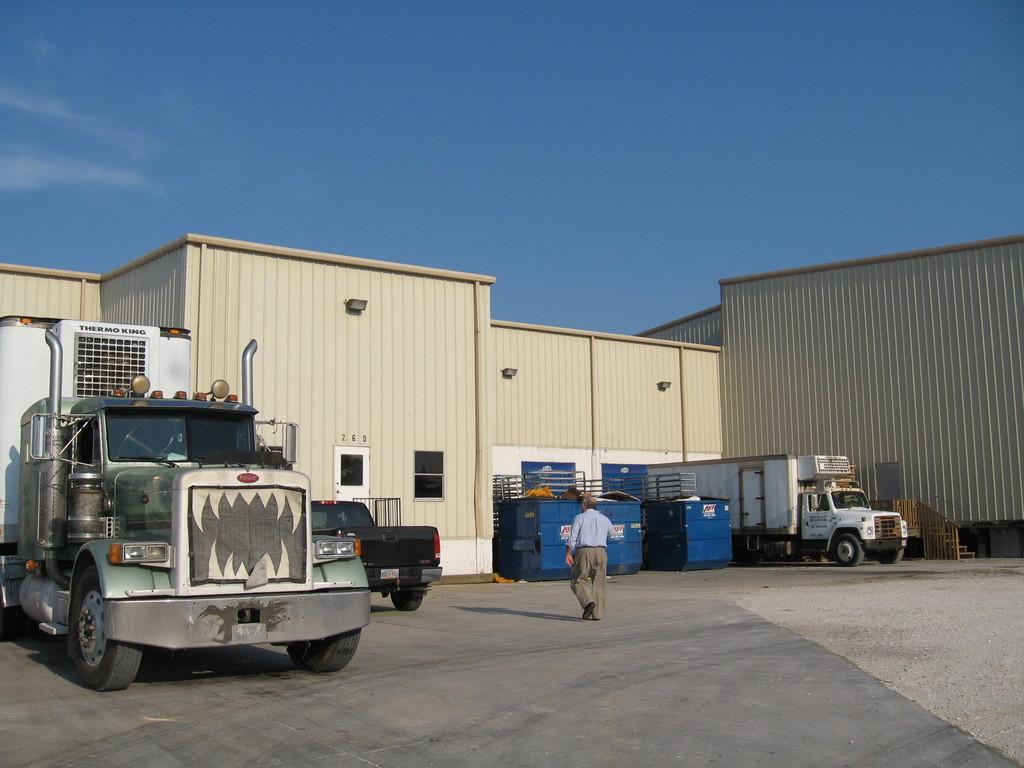In one or two sentences, can you explain what this image depicts? In the foreground of this picture, there is a truck on the left side of the image. In the background, there is a man walking on the ground, building, vehicles, and the sky. 